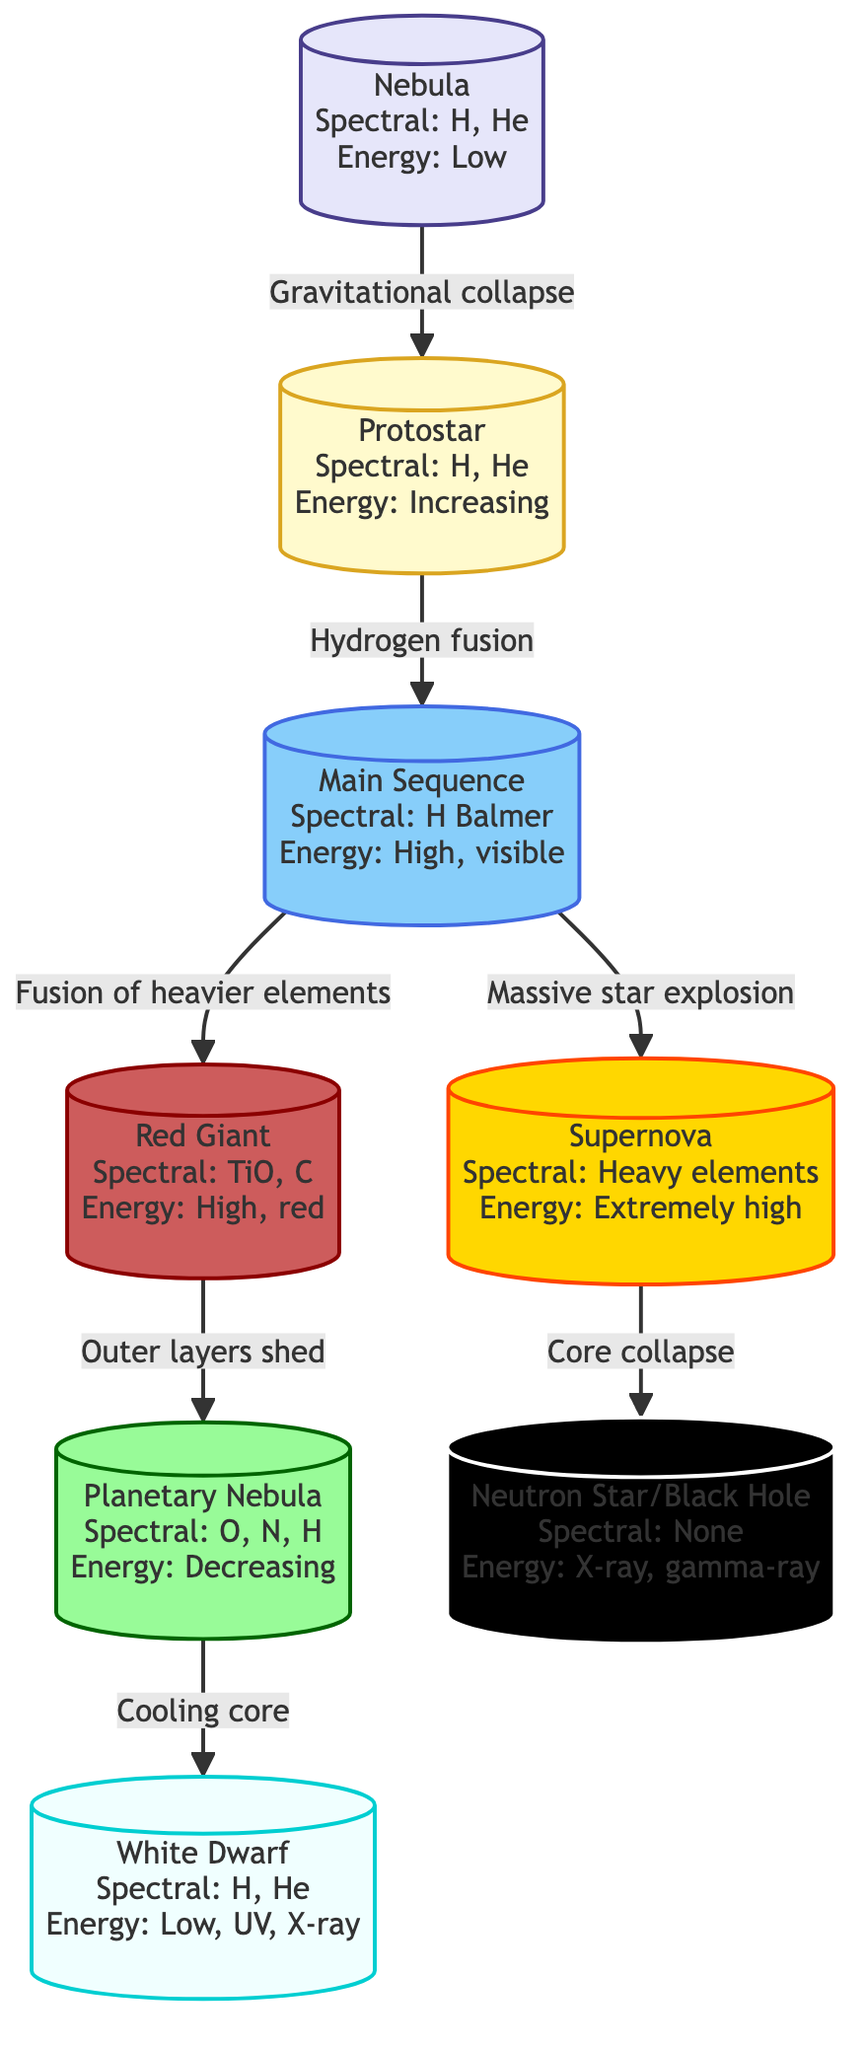What is the first stage of a star's life cycle? The diagram starts with a node labeled "Nebula," which is the initial stage in the life cycle of a star.
Answer: Nebula Which energy emission pattern is associated with the Main Sequence stage? The Main Sequence stage is described in the diagram as having "High, visible" energy emission.
Answer: High, visible What spectral lines are present at the Red Giant stage? The diagram specifies that the Red Giant stage has "TiO, C" spectral lines, indicating the presence of these elements in that phase.
Answer: TiO, C How many distinct stages are there before a Neutron Star/Black Hole is formed? By counting the nodes leading to the "Neutron Star/Black Hole" stage, we see there are five stages: Nebula, Protostar, Main Sequence, Red Giant, and Supernova.
Answer: 5 What happens after the Main Sequence stage in massive stars? For massive stars, the flowchart shows that after the Main Sequence stage, the process "Massive star explosion" leads directly to the Supernova stage.
Answer: Massive star explosion What type of energy emission is associated with the White Dwarf stage? According to the diagram, the White Dwarf stage has "Low, UV, X-ray" energy emission patterns.
Answer: Low, UV, X-ray What is the process leading from Red Giant to Planetary Nebula? The diagram indicates that the transition from Red Giant to Planetary Nebula occurs when "Outer layers shed."
Answer: Outer layers shed What is the final stage after a Supernova explosion? The flowchart concludes with the Neutron Star/Black Hole stage, which follows the Supernova explosion.
Answer: Neutron Star/Black Hole Which stage emits "Extremely high" energy? The Supernova stage is specifically identified in the diagram as having "Extremely high" energy emission.
Answer: Extremely high 